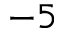<formula> <loc_0><loc_0><loc_500><loc_500>- 5</formula> 